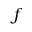Convert formula to latex. <formula><loc_0><loc_0><loc_500><loc_500>f</formula> 